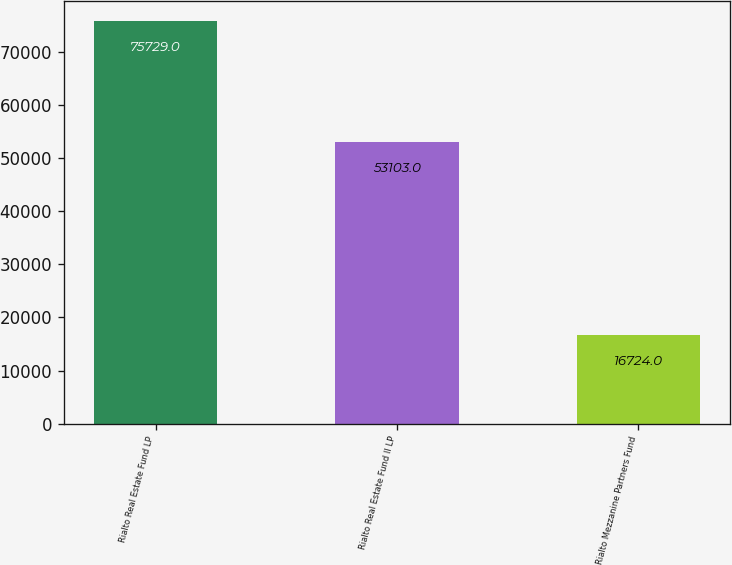Convert chart to OTSL. <chart><loc_0><loc_0><loc_500><loc_500><bar_chart><fcel>Rialto Real Estate Fund LP<fcel>Rialto Real Estate Fund II LP<fcel>Rialto Mezzanine Partners Fund<nl><fcel>75729<fcel>53103<fcel>16724<nl></chart> 